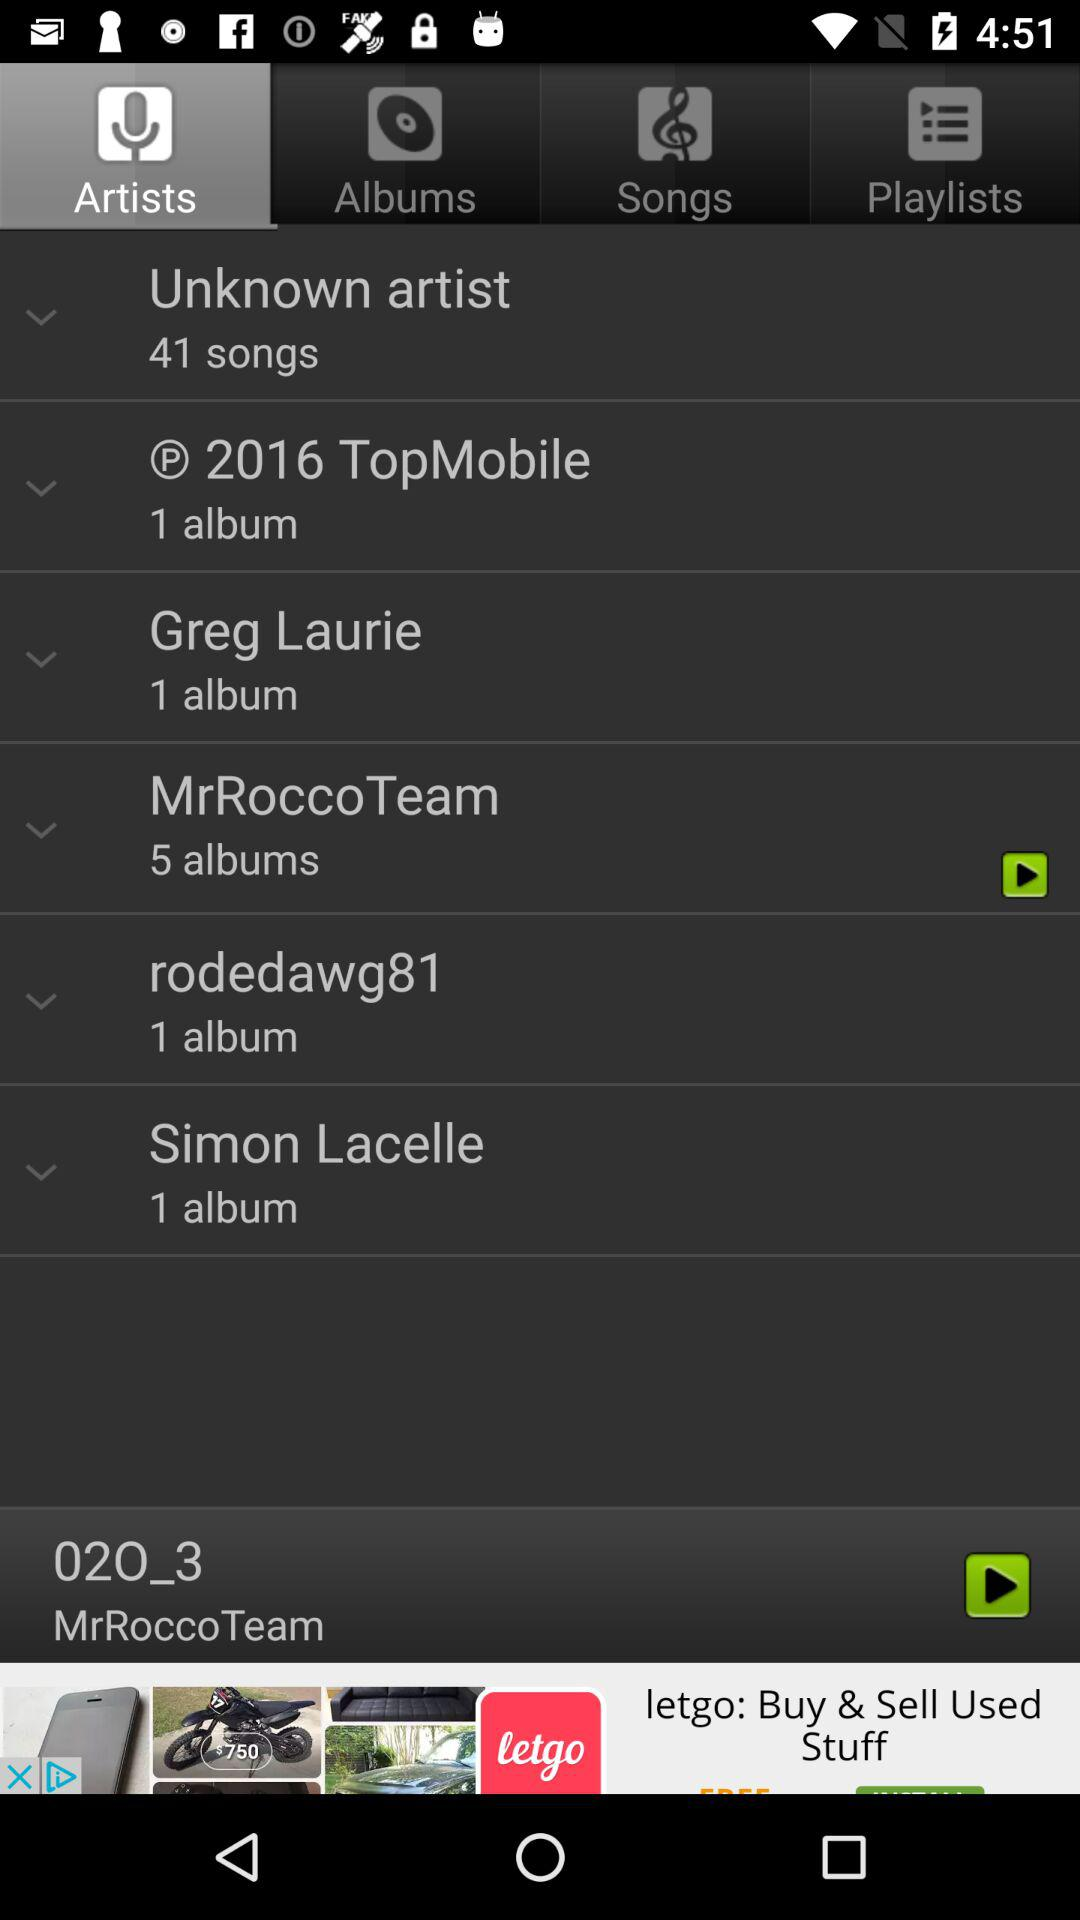How many albums are there by Simon Lacelle? There is 1 album by Simon Lacelle. 